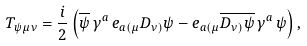Convert formula to latex. <formula><loc_0><loc_0><loc_500><loc_500>T _ { \psi \, \mu \nu } = \frac { i } { 2 } \left ( \overline { \psi } \, \gamma ^ { a } \, e _ { a ( \mu } D _ { \nu ) } \psi - e _ { a ( \mu } \overline { D _ { \nu ) } \psi } \, \gamma ^ { a } \, \psi \right ) ,</formula> 